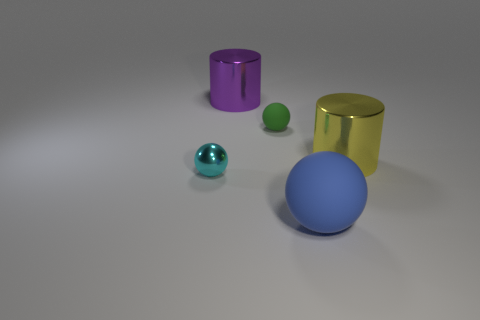Add 1 big purple cylinders. How many objects exist? 6 Subtract all cylinders. How many objects are left? 3 Subtract all large blue rubber objects. Subtract all tiny green matte spheres. How many objects are left? 3 Add 3 purple cylinders. How many purple cylinders are left? 4 Add 2 purple cylinders. How many purple cylinders exist? 3 Subtract 1 blue spheres. How many objects are left? 4 